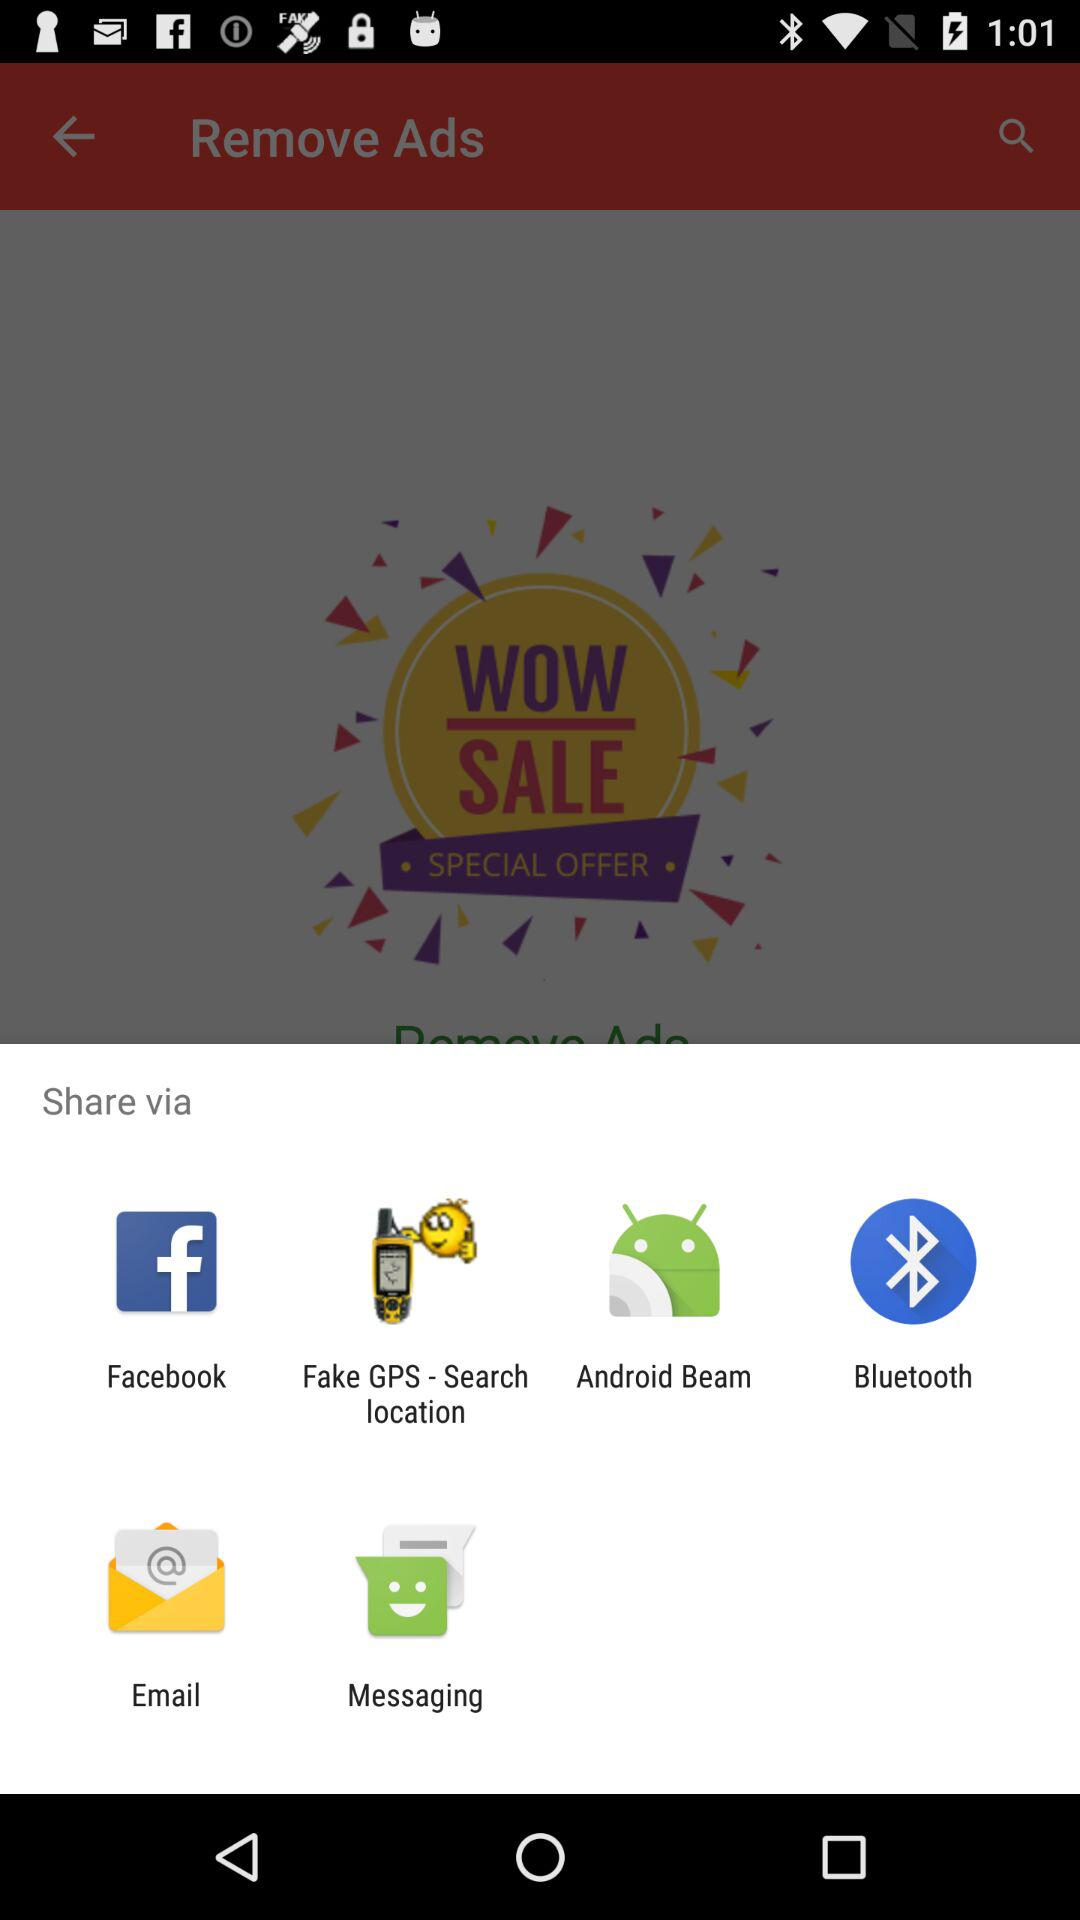Which applications can be used to share the data? The applications that can be used to share the data are "Facebook", "Fake GPS - Search location", "Android Beam", "Bluetooth", "Email" and "Messaging". 